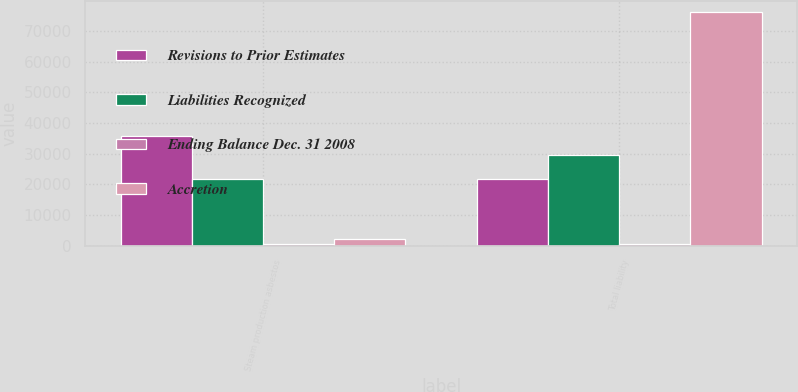Convert chart to OTSL. <chart><loc_0><loc_0><loc_500><loc_500><stacked_bar_chart><ecel><fcel>Steam production asbestos<fcel>Total liability<nl><fcel>Revisions to Prior Estimates<fcel>35807<fcel>21721<nl><fcel>Liabilities Recognized<fcel>21721<fcel>29464<nl><fcel>Ending Balance Dec. 31 2008<fcel>500<fcel>500<nl><fcel>Accretion<fcel>2165<fcel>76064<nl></chart> 